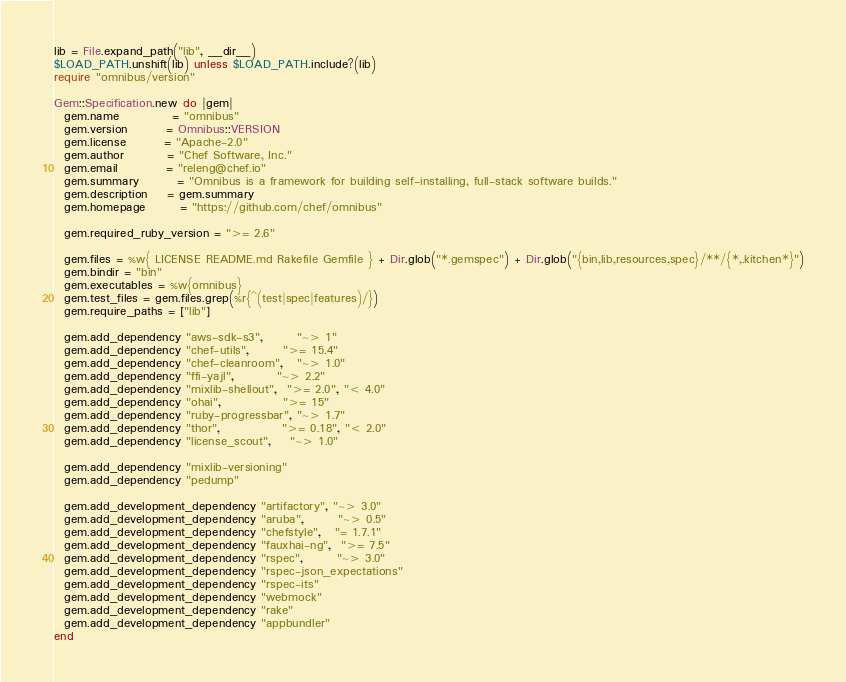<code> <loc_0><loc_0><loc_500><loc_500><_Ruby_>lib = File.expand_path("lib", __dir__)
$LOAD_PATH.unshift(lib) unless $LOAD_PATH.include?(lib)
require "omnibus/version"

Gem::Specification.new do |gem|
  gem.name           = "omnibus"
  gem.version        = Omnibus::VERSION
  gem.license        = "Apache-2.0"
  gem.author         = "Chef Software, Inc."
  gem.email          = "releng@chef.io"
  gem.summary        = "Omnibus is a framework for building self-installing, full-stack software builds."
  gem.description    = gem.summary
  gem.homepage       = "https://github.com/chef/omnibus"

  gem.required_ruby_version = ">= 2.6"

  gem.files = %w{ LICENSE README.md Rakefile Gemfile } + Dir.glob("*.gemspec") + Dir.glob("{bin,lib,resources,spec}/**/{*,.kitchen*}")
  gem.bindir = "bin"
  gem.executables = %w{omnibus}
  gem.test_files = gem.files.grep(%r{^(test|spec|features)/})
  gem.require_paths = ["lib"]

  gem.add_dependency "aws-sdk-s3",       "~> 1"
  gem.add_dependency "chef-utils",       ">= 15.4"
  gem.add_dependency "chef-cleanroom",   "~> 1.0"
  gem.add_dependency "ffi-yajl",         "~> 2.2"
  gem.add_dependency "mixlib-shellout",  ">= 2.0", "< 4.0"
  gem.add_dependency "ohai",             ">= 15"
  gem.add_dependency "ruby-progressbar", "~> 1.7"
  gem.add_dependency "thor",             ">= 0.18", "< 2.0"
  gem.add_dependency "license_scout",    "~> 1.0"

  gem.add_dependency "mixlib-versioning"
  gem.add_dependency "pedump"

  gem.add_development_dependency "artifactory", "~> 3.0"
  gem.add_development_dependency "aruba",       "~> 0.5"
  gem.add_development_dependency "chefstyle",   "= 1.7.1"
  gem.add_development_dependency "fauxhai-ng",  ">= 7.5"
  gem.add_development_dependency "rspec",       "~> 3.0"
  gem.add_development_dependency "rspec-json_expectations"
  gem.add_development_dependency "rspec-its"
  gem.add_development_dependency "webmock"
  gem.add_development_dependency "rake"
  gem.add_development_dependency "appbundler"
end
</code> 